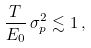<formula> <loc_0><loc_0><loc_500><loc_500>\frac { T } { E _ { 0 } } \, \sigma _ { p } ^ { 2 } \lesssim 1 \, ,</formula> 